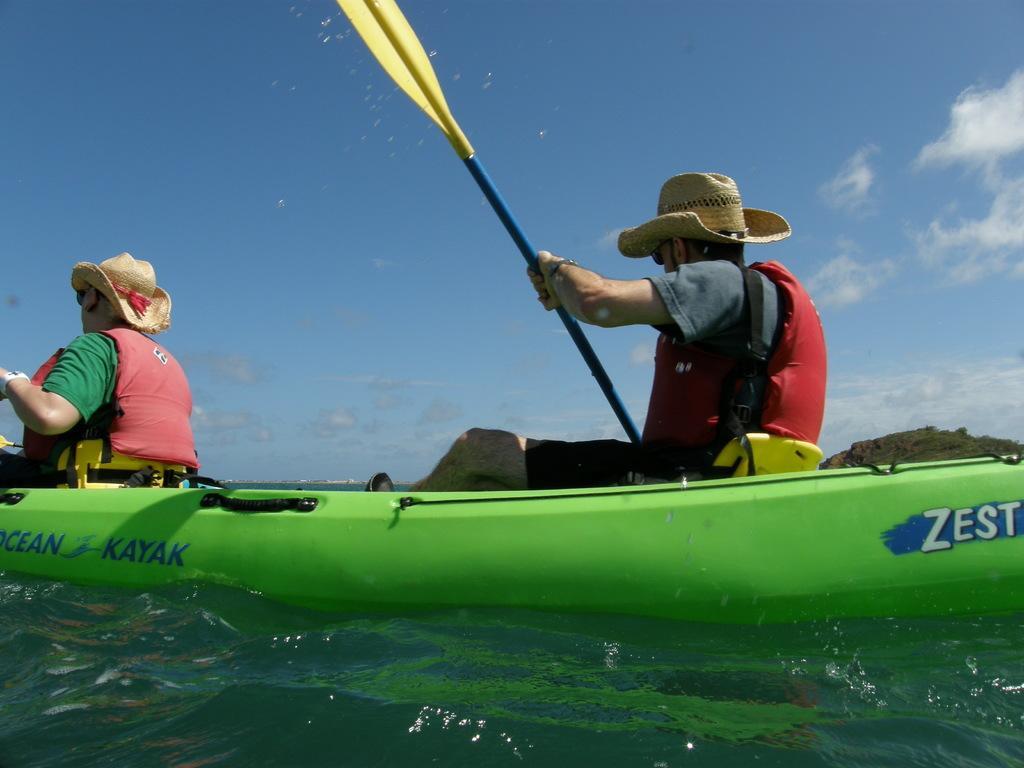How would you summarize this image in a sentence or two? In this image, we can see people on the boat and are wearing hats and safety jackets and are holding sticks. At the top, there are clouds in the sky and we can see hills and at the bottom, there is water. 